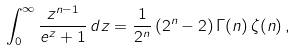<formula> <loc_0><loc_0><loc_500><loc_500>\int _ { 0 } ^ { \infty } \frac { z ^ { n - 1 } } { e ^ { z } + 1 } \, d z = \frac { 1 } { 2 ^ { n } } \, ( 2 ^ { n } - 2 ) \, \Gamma ( n ) \, \zeta ( n ) \, ,</formula> 